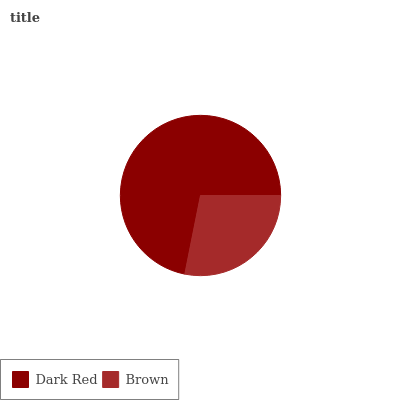Is Brown the minimum?
Answer yes or no. Yes. Is Dark Red the maximum?
Answer yes or no. Yes. Is Brown the maximum?
Answer yes or no. No. Is Dark Red greater than Brown?
Answer yes or no. Yes. Is Brown less than Dark Red?
Answer yes or no. Yes. Is Brown greater than Dark Red?
Answer yes or no. No. Is Dark Red less than Brown?
Answer yes or no. No. Is Dark Red the high median?
Answer yes or no. Yes. Is Brown the low median?
Answer yes or no. Yes. Is Brown the high median?
Answer yes or no. No. Is Dark Red the low median?
Answer yes or no. No. 